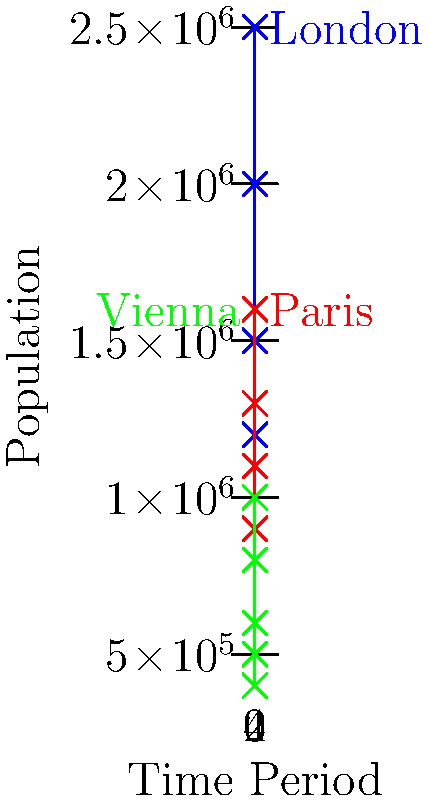Based on the population growth trends depicted in the graph for London, Paris, and Vienna during the time periods typically featured in the author's novels, which city experienced the most significant increase in population between the first and last time periods shown? To determine which city experienced the most significant increase in population, we need to calculate the population change for each city between the first and last time periods:

1. London:
   - First period population: 1,000,000
   - Last period population: 2,500,000
   - Change: 2,500,000 - 1,000,000 = 1,500,000

2. Paris:
   - First period population: 800,000
   - Last period population: 1,600,000
   - Change: 1,600,000 - 800,000 = 800,000

3. Vienna:
   - First period population: 400,000
   - Last period population: 1,000,000
   - Change: 1,000,000 - 400,000 = 600,000

Comparing these changes:
London: 1,500,000
Paris: 800,000
Vienna: 600,000

London has the largest increase in population between the first and last time periods.
Answer: London 